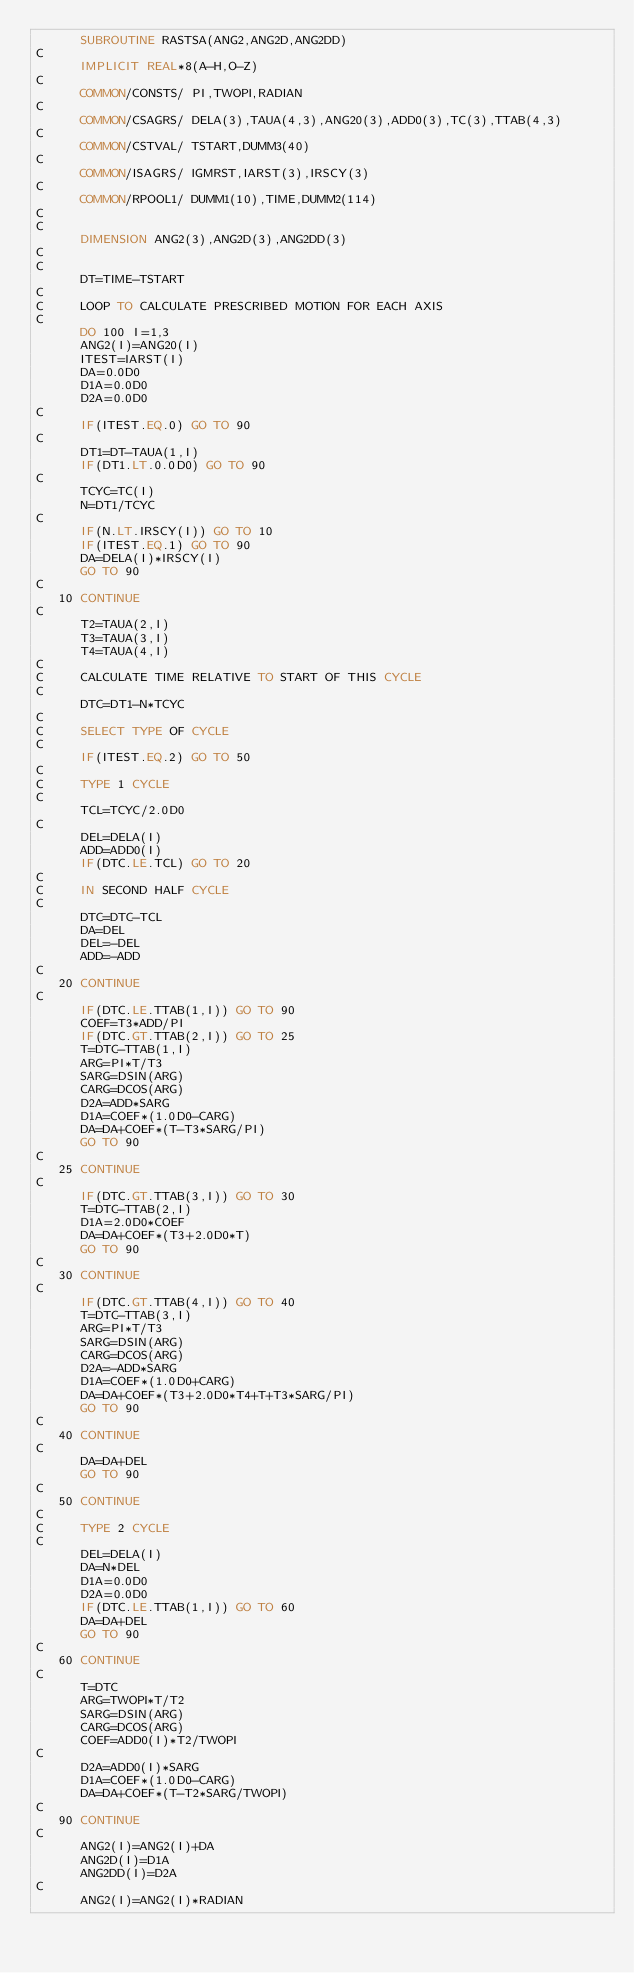<code> <loc_0><loc_0><loc_500><loc_500><_FORTRAN_>      SUBROUTINE RASTSA(ANG2,ANG2D,ANG2DD)
C
      IMPLICIT REAL*8(A-H,O-Z)
C
      COMMON/CONSTS/ PI,TWOPI,RADIAN
C
      COMMON/CSAGRS/ DELA(3),TAUA(4,3),ANG20(3),ADD0(3),TC(3),TTAB(4,3)
C
      COMMON/CSTVAL/ TSTART,DUMM3(40)
C
      COMMON/ISAGRS/ IGMRST,IARST(3),IRSCY(3)
C
      COMMON/RPOOL1/ DUMM1(10),TIME,DUMM2(114)
C
C
      DIMENSION ANG2(3),ANG2D(3),ANG2DD(3)
C
C
      DT=TIME-TSTART
C
C     LOOP TO CALCULATE PRESCRIBED MOTION FOR EACH AXIS
C
      DO 100 I=1,3
      ANG2(I)=ANG20(I)
      ITEST=IARST(I)
      DA=0.0D0
      D1A=0.0D0
      D2A=0.0D0
C
      IF(ITEST.EQ.0) GO TO 90
C
      DT1=DT-TAUA(1,I)
      IF(DT1.LT.0.0D0) GO TO 90
C
      TCYC=TC(I)
      N=DT1/TCYC
C
      IF(N.LT.IRSCY(I)) GO TO 10
      IF(ITEST.EQ.1) GO TO 90
      DA=DELA(I)*IRSCY(I)
      GO TO 90
C
   10 CONTINUE
C
      T2=TAUA(2,I)
      T3=TAUA(3,I)
      T4=TAUA(4,I)
C
C     CALCULATE TIME RELATIVE TO START OF THIS CYCLE
C
      DTC=DT1-N*TCYC
C
C     SELECT TYPE OF CYCLE
C
      IF(ITEST.EQ.2) GO TO 50
C
C     TYPE 1 CYCLE
C
      TCL=TCYC/2.0D0
C
      DEL=DELA(I)
      ADD=ADD0(I)
      IF(DTC.LE.TCL) GO TO 20
C
C     IN SECOND HALF CYCLE
C
      DTC=DTC-TCL
      DA=DEL
      DEL=-DEL
      ADD=-ADD
C
   20 CONTINUE
C
      IF(DTC.LE.TTAB(1,I)) GO TO 90
      COEF=T3*ADD/PI
      IF(DTC.GT.TTAB(2,I)) GO TO 25
      T=DTC-TTAB(1,I)
      ARG=PI*T/T3
      SARG=DSIN(ARG)
      CARG=DCOS(ARG)
      D2A=ADD*SARG
      D1A=COEF*(1.0D0-CARG)
      DA=DA+COEF*(T-T3*SARG/PI)
      GO TO 90
C
   25 CONTINUE
C
      IF(DTC.GT.TTAB(3,I)) GO TO 30
      T=DTC-TTAB(2,I)
      D1A=2.0D0*COEF
      DA=DA+COEF*(T3+2.0D0*T)
      GO TO 90
C
   30 CONTINUE
C
      IF(DTC.GT.TTAB(4,I)) GO TO 40
      T=DTC-TTAB(3,I)
      ARG=PI*T/T3
      SARG=DSIN(ARG)
      CARG=DCOS(ARG)
      D2A=-ADD*SARG
      D1A=COEF*(1.0D0+CARG)
      DA=DA+COEF*(T3+2.0D0*T4+T+T3*SARG/PI)
      GO TO 90
C
   40 CONTINUE
C
      DA=DA+DEL
      GO TO 90
C
   50 CONTINUE
C
C     TYPE 2 CYCLE
C
      DEL=DELA(I)
      DA=N*DEL
      D1A=0.0D0
      D2A=0.0D0
      IF(DTC.LE.TTAB(1,I)) GO TO 60
      DA=DA+DEL
      GO TO 90
C
   60 CONTINUE
C
      T=DTC
      ARG=TWOPI*T/T2
      SARG=DSIN(ARG)
      CARG=DCOS(ARG)
      COEF=ADD0(I)*T2/TWOPI
C
      D2A=ADD0(I)*SARG
      D1A=COEF*(1.0D0-CARG)
      DA=DA+COEF*(T-T2*SARG/TWOPI)
C
   90 CONTINUE
C
      ANG2(I)=ANG2(I)+DA
      ANG2D(I)=D1A
      ANG2DD(I)=D2A
C
      ANG2(I)=ANG2(I)*RADIAN</code> 